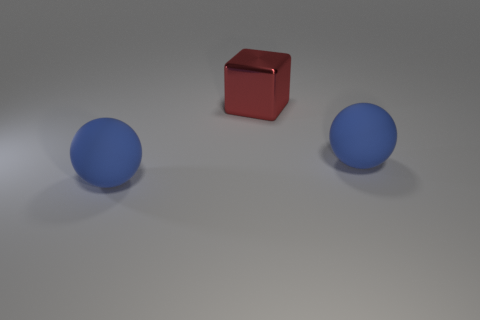Add 2 tiny red metal objects. How many objects exist? 5 Subtract all cubes. How many objects are left? 2 Subtract all small yellow matte spheres. Subtract all big blue matte things. How many objects are left? 1 Add 2 red objects. How many red objects are left? 3 Add 2 big blue metallic objects. How many big blue metallic objects exist? 2 Subtract 0 red balls. How many objects are left? 3 